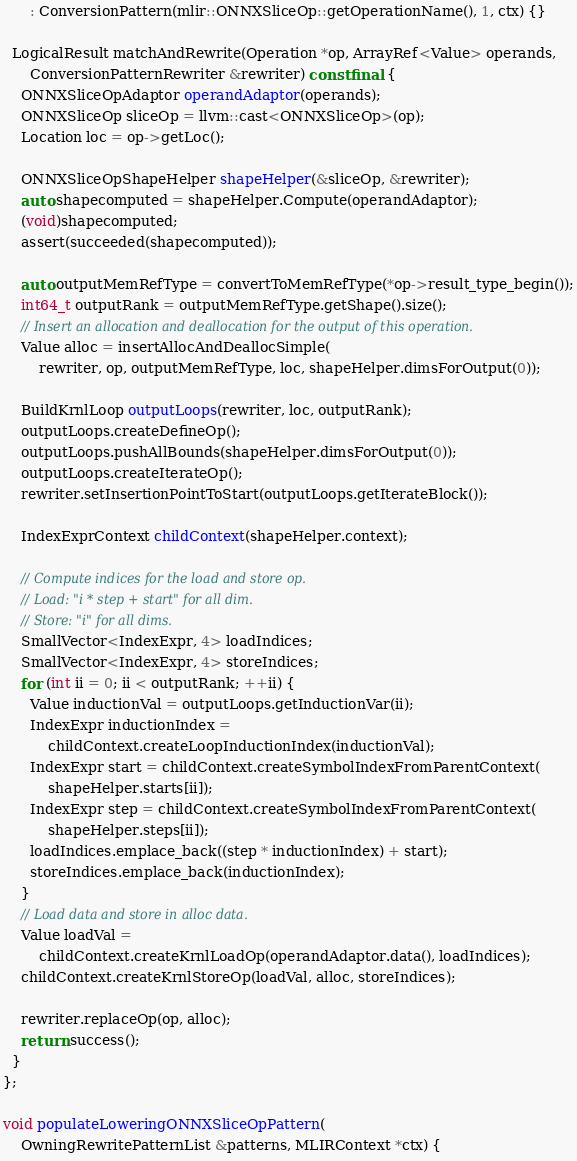Convert code to text. <code><loc_0><loc_0><loc_500><loc_500><_C++_>      : ConversionPattern(mlir::ONNXSliceOp::getOperationName(), 1, ctx) {}

  LogicalResult matchAndRewrite(Operation *op, ArrayRef<Value> operands,
      ConversionPatternRewriter &rewriter) const final {
    ONNXSliceOpAdaptor operandAdaptor(operands);
    ONNXSliceOp sliceOp = llvm::cast<ONNXSliceOp>(op);
    Location loc = op->getLoc();

    ONNXSliceOpShapeHelper shapeHelper(&sliceOp, &rewriter);
    auto shapecomputed = shapeHelper.Compute(operandAdaptor);
    (void)shapecomputed;
    assert(succeeded(shapecomputed));

    auto outputMemRefType = convertToMemRefType(*op->result_type_begin());
    int64_t outputRank = outputMemRefType.getShape().size();
    // Insert an allocation and deallocation for the output of this operation.
    Value alloc = insertAllocAndDeallocSimple(
        rewriter, op, outputMemRefType, loc, shapeHelper.dimsForOutput(0));

    BuildKrnlLoop outputLoops(rewriter, loc, outputRank);
    outputLoops.createDefineOp();
    outputLoops.pushAllBounds(shapeHelper.dimsForOutput(0));
    outputLoops.createIterateOp();
    rewriter.setInsertionPointToStart(outputLoops.getIterateBlock());

    IndexExprContext childContext(shapeHelper.context);

    // Compute indices for the load and store op.
    // Load: "i * step + start" for all dim.
    // Store: "i" for all dims.
    SmallVector<IndexExpr, 4> loadIndices;
    SmallVector<IndexExpr, 4> storeIndices;
    for (int ii = 0; ii < outputRank; ++ii) {
      Value inductionVal = outputLoops.getInductionVar(ii);
      IndexExpr inductionIndex =
          childContext.createLoopInductionIndex(inductionVal);
      IndexExpr start = childContext.createSymbolIndexFromParentContext(
          shapeHelper.starts[ii]);
      IndexExpr step = childContext.createSymbolIndexFromParentContext(
          shapeHelper.steps[ii]);
      loadIndices.emplace_back((step * inductionIndex) + start);
      storeIndices.emplace_back(inductionIndex);
    }
    // Load data and store in alloc data.
    Value loadVal =
        childContext.createKrnlLoadOp(operandAdaptor.data(), loadIndices);
    childContext.createKrnlStoreOp(loadVal, alloc, storeIndices);

    rewriter.replaceOp(op, alloc);
    return success();
  }
};

void populateLoweringONNXSliceOpPattern(
    OwningRewritePatternList &patterns, MLIRContext *ctx) {</code> 